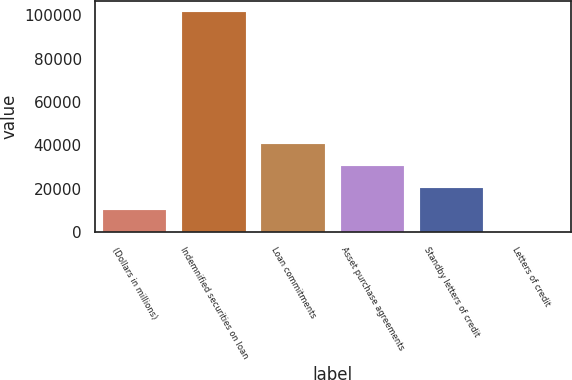Convert chart to OTSL. <chart><loc_0><loc_0><loc_500><loc_500><bar_chart><fcel>(Dollars in millions)<fcel>Indemnified securities on loan<fcel>Loan commitments<fcel>Asset purchase agreements<fcel>Standby letters of credit<fcel>Letters of credit<nl><fcel>10340<fcel>101438<fcel>40706<fcel>30584<fcel>20462<fcel>218<nl></chart> 